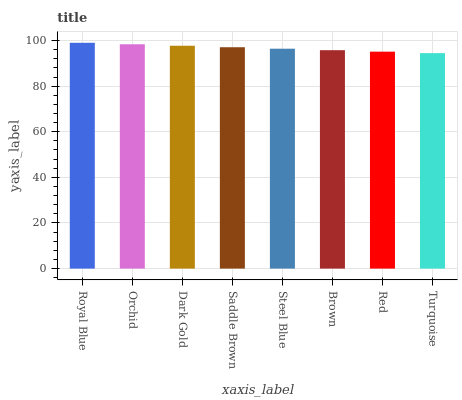Is Turquoise the minimum?
Answer yes or no. Yes. Is Royal Blue the maximum?
Answer yes or no. Yes. Is Orchid the minimum?
Answer yes or no. No. Is Orchid the maximum?
Answer yes or no. No. Is Royal Blue greater than Orchid?
Answer yes or no. Yes. Is Orchid less than Royal Blue?
Answer yes or no. Yes. Is Orchid greater than Royal Blue?
Answer yes or no. No. Is Royal Blue less than Orchid?
Answer yes or no. No. Is Saddle Brown the high median?
Answer yes or no. Yes. Is Steel Blue the low median?
Answer yes or no. Yes. Is Steel Blue the high median?
Answer yes or no. No. Is Saddle Brown the low median?
Answer yes or no. No. 